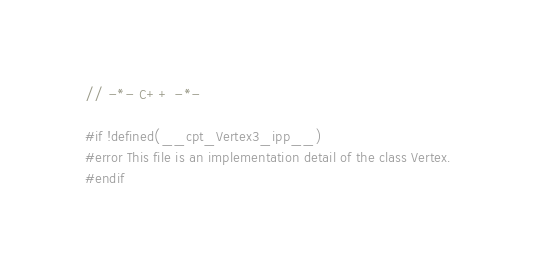Convert code to text. <code><loc_0><loc_0><loc_500><loc_500><_C++_>// -*- C++ -*-

#if !defined(__cpt_Vertex3_ipp__)
#error This file is an implementation detail of the class Vertex.
#endif
</code> 